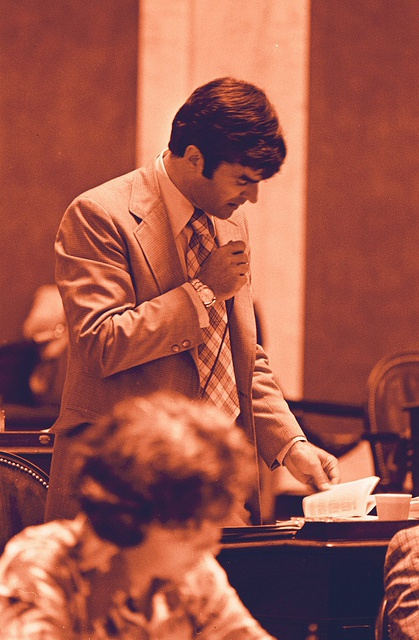Describe the objects in this image and their specific colors. I can see people in brown and salmon tones, people in brown and salmon tones, chair in brown and black tones, tie in brown, salmon, and maroon tones, and people in brown, maroon, and salmon tones in this image. 